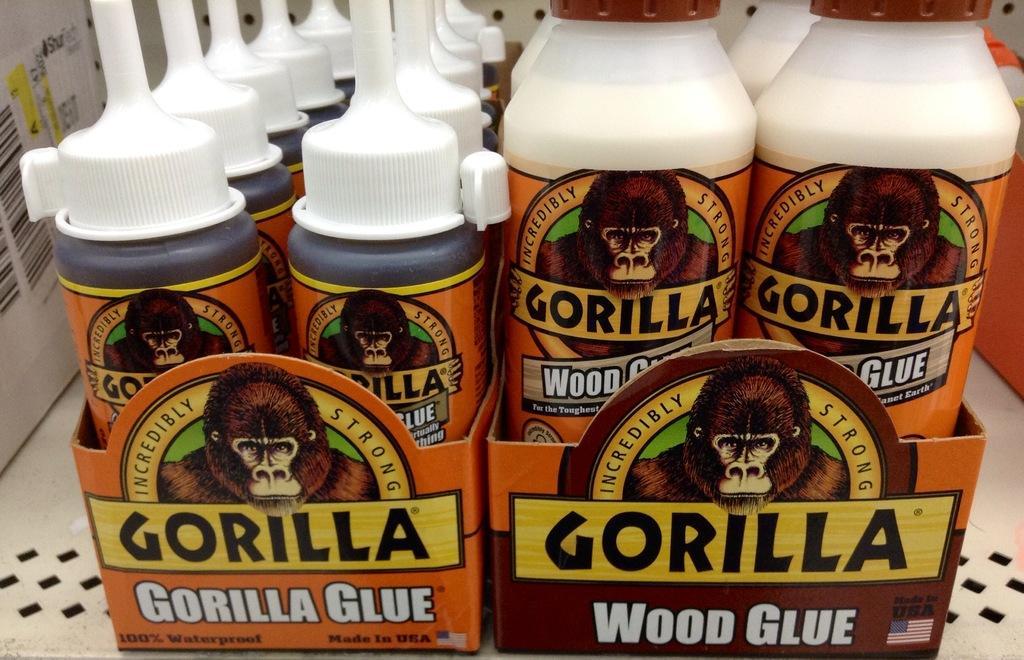In one or two sentences, can you explain what this image depicts? In this image we can see a wood glue bottles. 